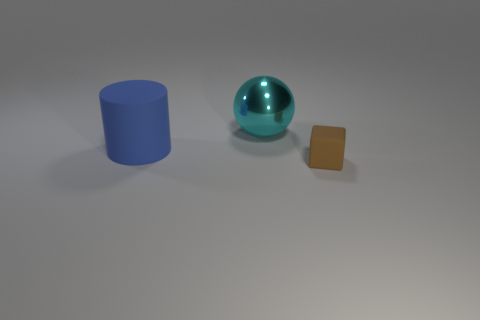The blue thing that is made of the same material as the small cube is what shape?
Offer a very short reply. Cylinder. There is a big sphere; are there any blue cylinders to the right of it?
Provide a succinct answer. No. Is the number of small brown objects that are behind the sphere less than the number of blue things?
Your response must be concise. Yes. What is the big ball made of?
Make the answer very short. Metal. The small object has what color?
Keep it short and to the point. Brown. The object that is behind the tiny rubber block and in front of the big cyan metal ball is what color?
Give a very brief answer. Blue. Is there any other thing that has the same material as the large sphere?
Your response must be concise. No. Does the cube have the same material as the big object behind the rubber cylinder?
Ensure brevity in your answer.  No. What is the size of the rubber thing to the right of the matte thing left of the small brown matte block?
Your answer should be very brief. Small. Is there anything else of the same color as the big matte object?
Offer a terse response. No. 